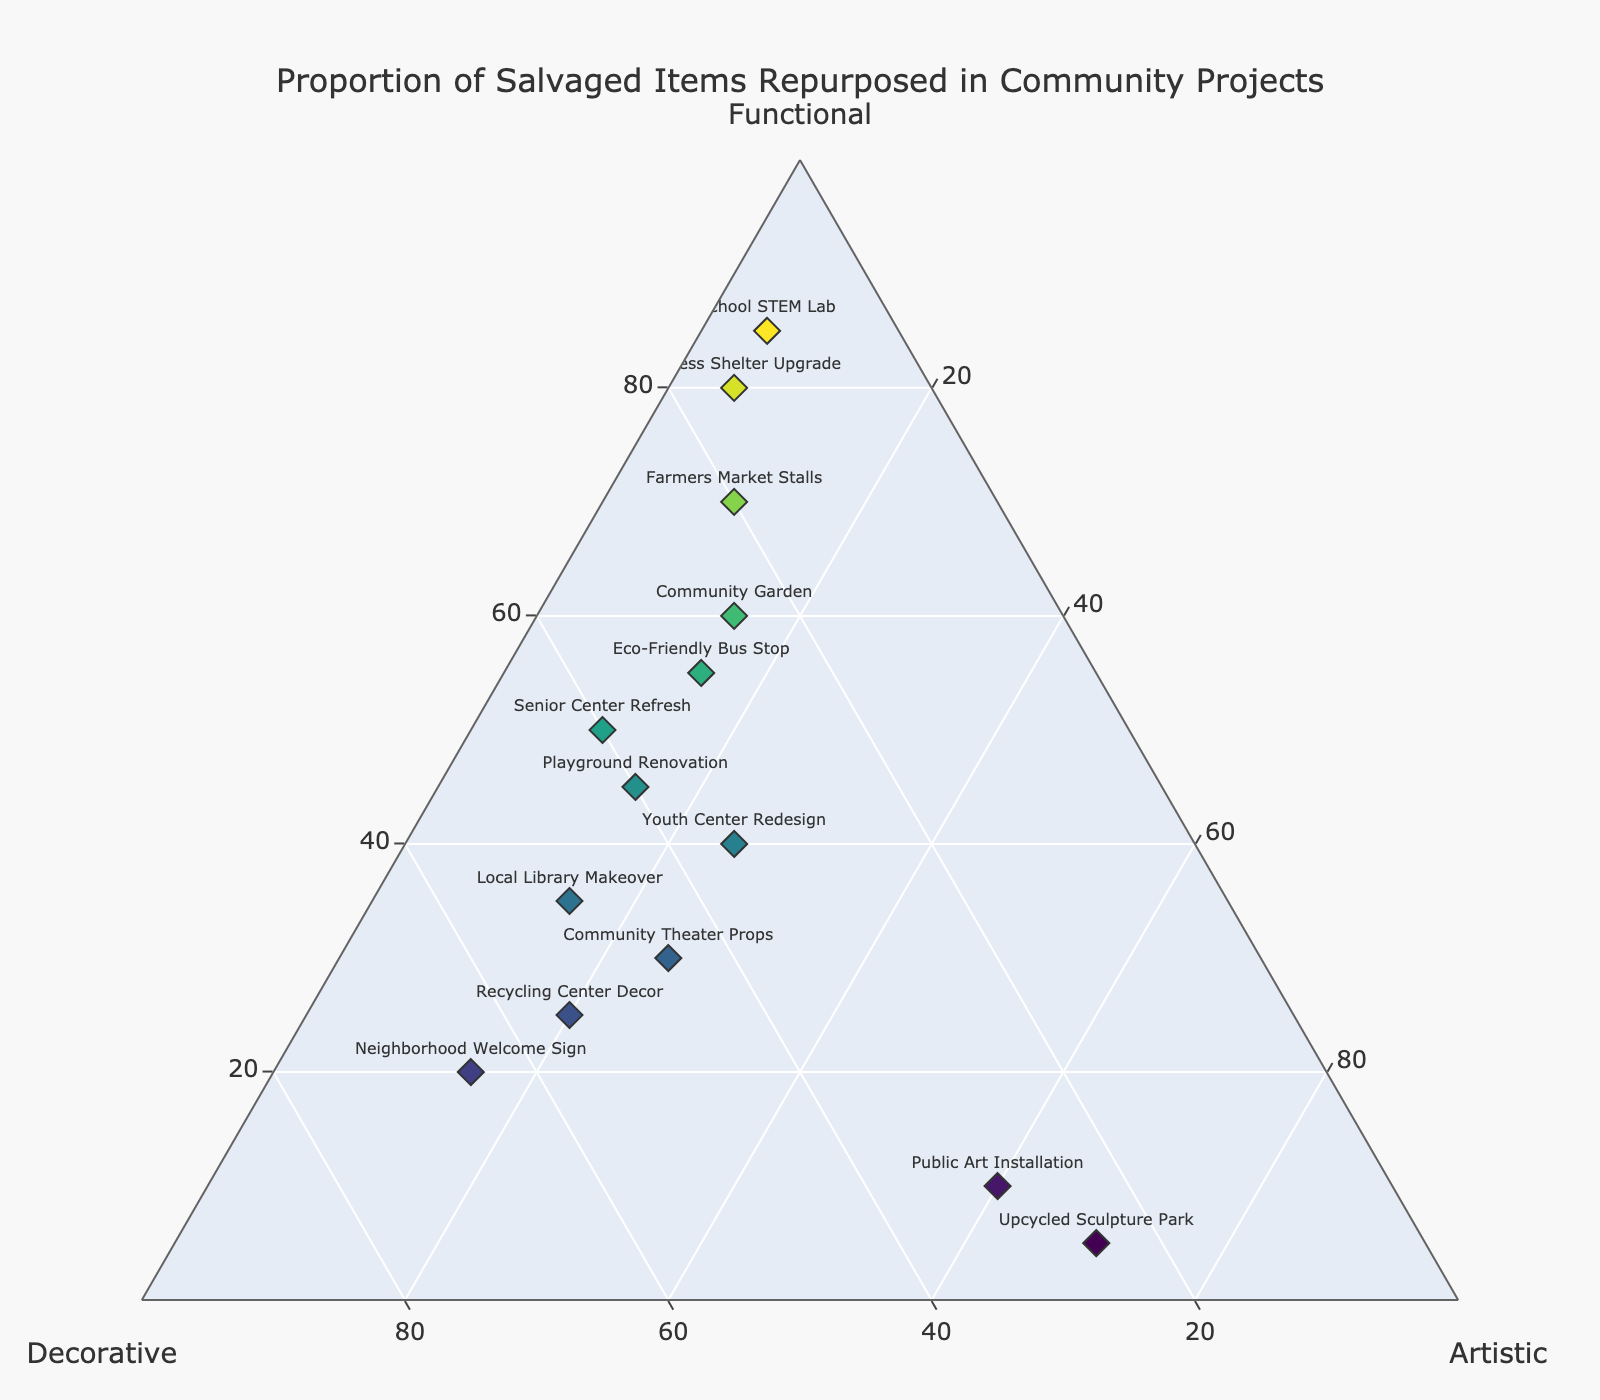How many projects are plotted on the ternary plot? By counting the number of markers (each representing a project) on the ternary plot, we can see there are a total of 14 data points.
Answer: 14 Which project has the highest proportion of items repurposed for functional purposes? From examining the ternary plot, the project with the highest point along the functional axis is the School STEM Lab, with 85% of items repurposed for functional purposes.
Answer: School STEM Lab What is the composition of the Artistic repurposing for the Upcycled Sculpture Park? The Upcycled Sculpture Park is located at a high point on the Artistic axis, showing 70% of the proportion dedicated to Artistic purposes.
Answer: 70% Which two projects have the same proportion of Artistic repurposing? On reviewing the Artistic axis, the Community Theater Props, and Youth Center Redesign both have an equal 25% proportion of items repurposed for Artistic purposes.
Answer: Community Theater Props and Youth Center Redesign Which project shows the most balanced distribution among Functional, Decorative, and Artistic repurposing? The Playground Renovation appears to be the most balanced as it has relatively equal proportions of repurposed items: 45% Functional, 40% Decorative, and 15% Artistic, making it close to the center.
Answer: Playground Renovation If you sum the proportions for Artistic repurposing in the Public Art Installation and Neighborhood Welcome Sign, what is the result? The Public Art Installation has 60% Artistic, and the Neighborhood Welcome Sign has 15% Artistic repurposing. Summing these gives 60% + 15% = 75%.
Answer: 75% Which project has the greatest disparity between Functional and Artistic purposes? The Homeless Shelter Upgrade shows the biggest gap with 80% Functional and only 5% Artistic purposes, making a disparity of 80% - 5% = 75%.
Answer: Homeless Shelter Upgrade How do the proportions of Decorative use compare between the Local Library Makeover and Recycling Center Decor? The ternary plot shows that the Local Library Makeover has 50% Decorative, while the Recycling Center Decor has a higher value of 55% Decorative use.
Answer: Recycling Center Decor What is the average proportion for Functional repurposing across all projects? By summing all the Functional percentages (60+45+10+80+35+40+20+55+50+5+30+70+25+85 = 610) and dividing by the number of projects (14), we find the average is 610 / 14 ≈ 43.57%.
Answer: 43.57% What proportion of the Playground Renovation project's repurposing is non-Functional? The Playground Renovation has 45% Functional, leaving 55% (100% - 45%) for combined Decorative and Artistic purposes.
Answer: 55% 